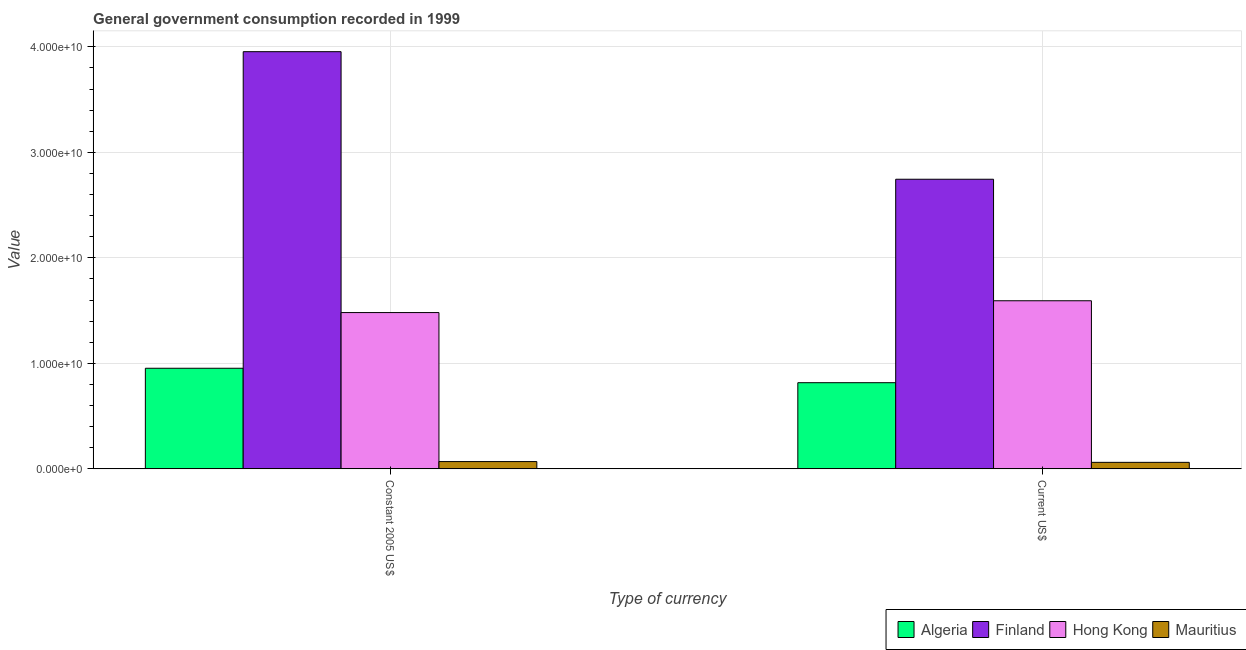How many groups of bars are there?
Keep it short and to the point. 2. Are the number of bars per tick equal to the number of legend labels?
Make the answer very short. Yes. Are the number of bars on each tick of the X-axis equal?
Provide a succinct answer. Yes. How many bars are there on the 2nd tick from the left?
Offer a very short reply. 4. What is the label of the 2nd group of bars from the left?
Your response must be concise. Current US$. What is the value consumed in current us$ in Mauritius?
Your answer should be compact. 6.15e+08. Across all countries, what is the maximum value consumed in current us$?
Give a very brief answer. 2.75e+1. Across all countries, what is the minimum value consumed in current us$?
Keep it short and to the point. 6.15e+08. In which country was the value consumed in constant 2005 us$ minimum?
Keep it short and to the point. Mauritius. What is the total value consumed in constant 2005 us$ in the graph?
Provide a succinct answer. 6.46e+1. What is the difference between the value consumed in current us$ in Finland and that in Mauritius?
Ensure brevity in your answer.  2.68e+1. What is the difference between the value consumed in current us$ in Mauritius and the value consumed in constant 2005 us$ in Algeria?
Your answer should be very brief. -8.92e+09. What is the average value consumed in constant 2005 us$ per country?
Give a very brief answer. 1.61e+1. What is the difference between the value consumed in constant 2005 us$ and value consumed in current us$ in Mauritius?
Provide a succinct answer. 7.44e+07. In how many countries, is the value consumed in constant 2005 us$ greater than 32000000000 ?
Provide a succinct answer. 1. What is the ratio of the value consumed in constant 2005 us$ in Hong Kong to that in Mauritius?
Keep it short and to the point. 21.49. Is the value consumed in current us$ in Algeria less than that in Hong Kong?
Offer a terse response. Yes. What does the 3rd bar from the right in Constant 2005 US$ represents?
Ensure brevity in your answer.  Finland. How many bars are there?
Provide a short and direct response. 8. What is the difference between two consecutive major ticks on the Y-axis?
Your answer should be compact. 1.00e+1. Where does the legend appear in the graph?
Make the answer very short. Bottom right. What is the title of the graph?
Give a very brief answer. General government consumption recorded in 1999. Does "Poland" appear as one of the legend labels in the graph?
Your answer should be compact. No. What is the label or title of the X-axis?
Offer a terse response. Type of currency. What is the label or title of the Y-axis?
Make the answer very short. Value. What is the Value of Algeria in Constant 2005 US$?
Your response must be concise. 9.53e+09. What is the Value in Finland in Constant 2005 US$?
Your response must be concise. 3.95e+1. What is the Value of Hong Kong in Constant 2005 US$?
Make the answer very short. 1.48e+1. What is the Value of Mauritius in Constant 2005 US$?
Give a very brief answer. 6.89e+08. What is the Value in Algeria in Current US$?
Make the answer very short. 8.17e+09. What is the Value in Finland in Current US$?
Provide a succinct answer. 2.75e+1. What is the Value of Hong Kong in Current US$?
Keep it short and to the point. 1.59e+1. What is the Value in Mauritius in Current US$?
Provide a succinct answer. 6.15e+08. Across all Type of currency, what is the maximum Value in Algeria?
Your answer should be compact. 9.53e+09. Across all Type of currency, what is the maximum Value of Finland?
Keep it short and to the point. 3.95e+1. Across all Type of currency, what is the maximum Value in Hong Kong?
Make the answer very short. 1.59e+1. Across all Type of currency, what is the maximum Value in Mauritius?
Your response must be concise. 6.89e+08. Across all Type of currency, what is the minimum Value in Algeria?
Your answer should be compact. 8.17e+09. Across all Type of currency, what is the minimum Value of Finland?
Keep it short and to the point. 2.75e+1. Across all Type of currency, what is the minimum Value in Hong Kong?
Provide a succinct answer. 1.48e+1. Across all Type of currency, what is the minimum Value of Mauritius?
Offer a very short reply. 6.15e+08. What is the total Value in Algeria in the graph?
Give a very brief answer. 1.77e+1. What is the total Value of Finland in the graph?
Make the answer very short. 6.70e+1. What is the total Value in Hong Kong in the graph?
Your response must be concise. 3.07e+1. What is the total Value in Mauritius in the graph?
Provide a succinct answer. 1.30e+09. What is the difference between the Value in Algeria in Constant 2005 US$ and that in Current US$?
Your answer should be compact. 1.37e+09. What is the difference between the Value of Finland in Constant 2005 US$ and that in Current US$?
Provide a succinct answer. 1.21e+1. What is the difference between the Value of Hong Kong in Constant 2005 US$ and that in Current US$?
Provide a succinct answer. -1.12e+09. What is the difference between the Value in Mauritius in Constant 2005 US$ and that in Current US$?
Your answer should be compact. 7.44e+07. What is the difference between the Value in Algeria in Constant 2005 US$ and the Value in Finland in Current US$?
Your answer should be compact. -1.79e+1. What is the difference between the Value of Algeria in Constant 2005 US$ and the Value of Hong Kong in Current US$?
Provide a succinct answer. -6.40e+09. What is the difference between the Value of Algeria in Constant 2005 US$ and the Value of Mauritius in Current US$?
Your answer should be very brief. 8.92e+09. What is the difference between the Value of Finland in Constant 2005 US$ and the Value of Hong Kong in Current US$?
Keep it short and to the point. 2.36e+1. What is the difference between the Value in Finland in Constant 2005 US$ and the Value in Mauritius in Current US$?
Your answer should be compact. 3.89e+1. What is the difference between the Value in Hong Kong in Constant 2005 US$ and the Value in Mauritius in Current US$?
Your answer should be very brief. 1.42e+1. What is the average Value of Algeria per Type of currency?
Provide a short and direct response. 8.85e+09. What is the average Value in Finland per Type of currency?
Give a very brief answer. 3.35e+1. What is the average Value of Hong Kong per Type of currency?
Make the answer very short. 1.54e+1. What is the average Value of Mauritius per Type of currency?
Your answer should be compact. 6.52e+08. What is the difference between the Value in Algeria and Value in Finland in Constant 2005 US$?
Offer a terse response. -3.00e+1. What is the difference between the Value of Algeria and Value of Hong Kong in Constant 2005 US$?
Make the answer very short. -5.28e+09. What is the difference between the Value of Algeria and Value of Mauritius in Constant 2005 US$?
Keep it short and to the point. 8.84e+09. What is the difference between the Value of Finland and Value of Hong Kong in Constant 2005 US$?
Provide a succinct answer. 2.47e+1. What is the difference between the Value in Finland and Value in Mauritius in Constant 2005 US$?
Offer a terse response. 3.89e+1. What is the difference between the Value in Hong Kong and Value in Mauritius in Constant 2005 US$?
Ensure brevity in your answer.  1.41e+1. What is the difference between the Value in Algeria and Value in Finland in Current US$?
Offer a very short reply. -1.93e+1. What is the difference between the Value of Algeria and Value of Hong Kong in Current US$?
Your answer should be compact. -7.77e+09. What is the difference between the Value in Algeria and Value in Mauritius in Current US$?
Make the answer very short. 7.55e+09. What is the difference between the Value of Finland and Value of Hong Kong in Current US$?
Provide a short and direct response. 1.15e+1. What is the difference between the Value in Finland and Value in Mauritius in Current US$?
Ensure brevity in your answer.  2.68e+1. What is the difference between the Value in Hong Kong and Value in Mauritius in Current US$?
Make the answer very short. 1.53e+1. What is the ratio of the Value in Algeria in Constant 2005 US$ to that in Current US$?
Offer a very short reply. 1.17. What is the ratio of the Value of Finland in Constant 2005 US$ to that in Current US$?
Keep it short and to the point. 1.44. What is the ratio of the Value in Hong Kong in Constant 2005 US$ to that in Current US$?
Your answer should be compact. 0.93. What is the ratio of the Value in Mauritius in Constant 2005 US$ to that in Current US$?
Give a very brief answer. 1.12. What is the difference between the highest and the second highest Value of Algeria?
Offer a terse response. 1.37e+09. What is the difference between the highest and the second highest Value in Finland?
Ensure brevity in your answer.  1.21e+1. What is the difference between the highest and the second highest Value in Hong Kong?
Give a very brief answer. 1.12e+09. What is the difference between the highest and the second highest Value in Mauritius?
Provide a short and direct response. 7.44e+07. What is the difference between the highest and the lowest Value of Algeria?
Your response must be concise. 1.37e+09. What is the difference between the highest and the lowest Value of Finland?
Your answer should be very brief. 1.21e+1. What is the difference between the highest and the lowest Value of Hong Kong?
Provide a succinct answer. 1.12e+09. What is the difference between the highest and the lowest Value in Mauritius?
Your response must be concise. 7.44e+07. 